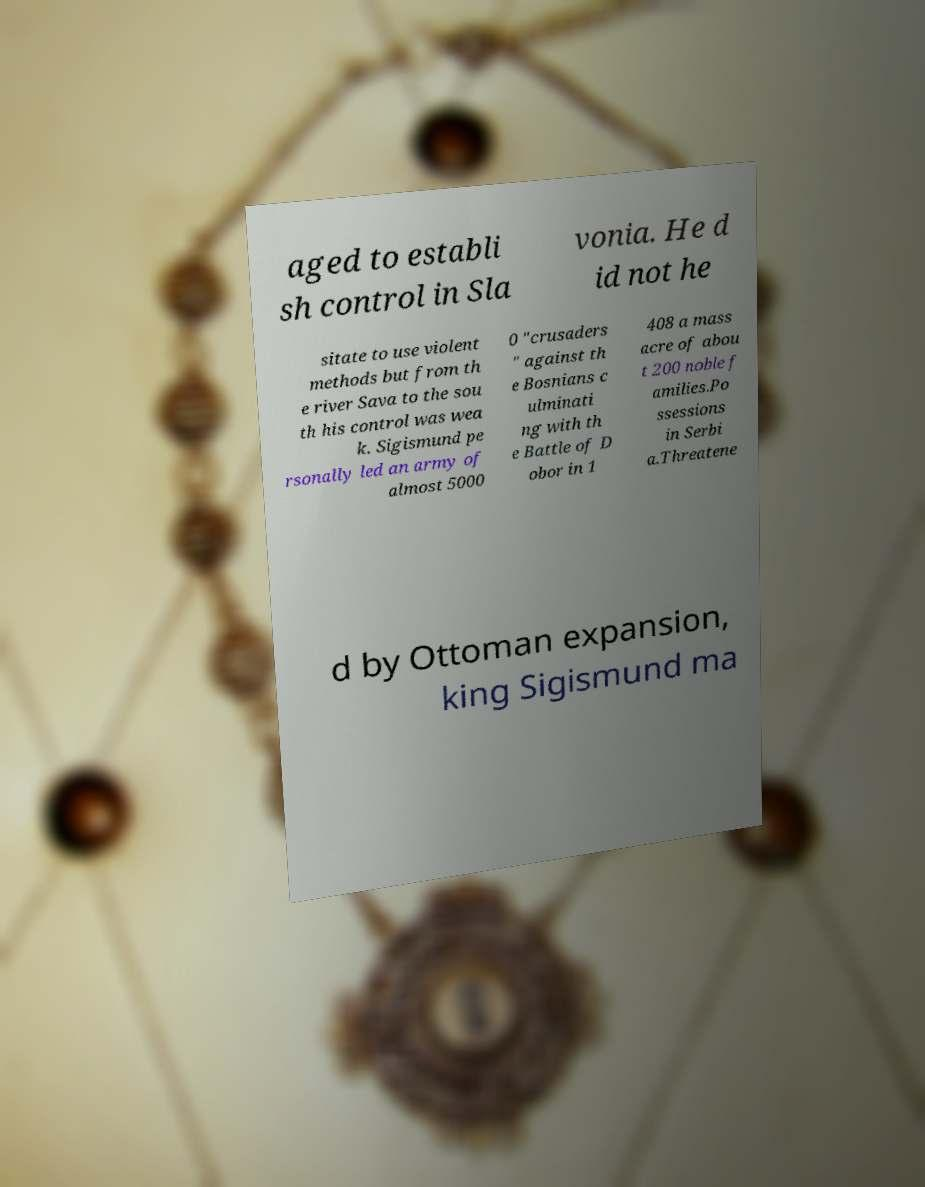Can you read and provide the text displayed in the image?This photo seems to have some interesting text. Can you extract and type it out for me? aged to establi sh control in Sla vonia. He d id not he sitate to use violent methods but from th e river Sava to the sou th his control was wea k. Sigismund pe rsonally led an army of almost 5000 0 "crusaders " against th e Bosnians c ulminati ng with th e Battle of D obor in 1 408 a mass acre of abou t 200 noble f amilies.Po ssessions in Serbi a.Threatene d by Ottoman expansion, king Sigismund ma 